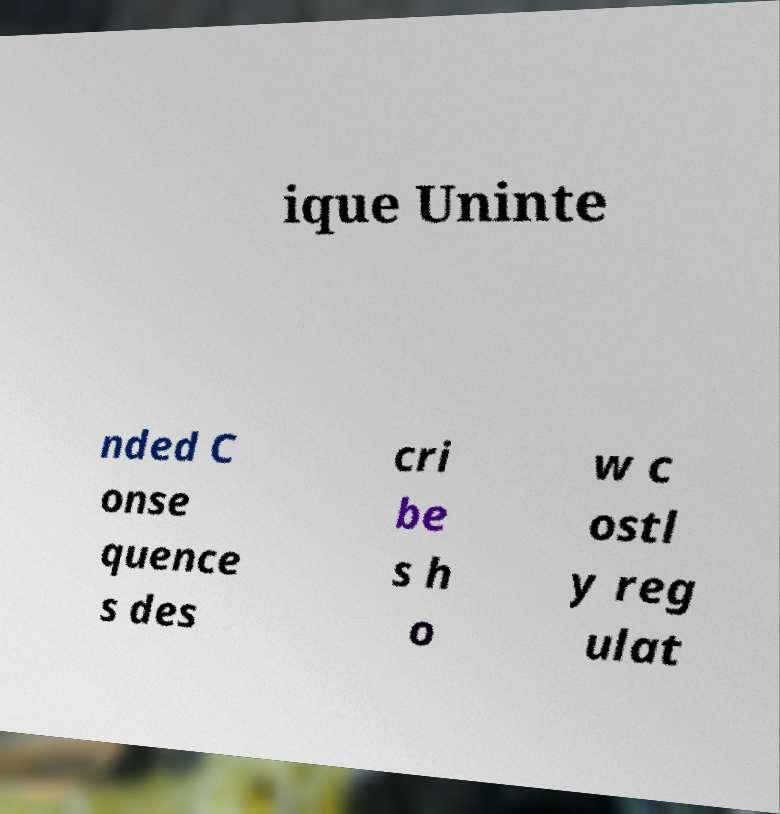Can you read and provide the text displayed in the image?This photo seems to have some interesting text. Can you extract and type it out for me? ique Uninte nded C onse quence s des cri be s h o w c ostl y reg ulat 